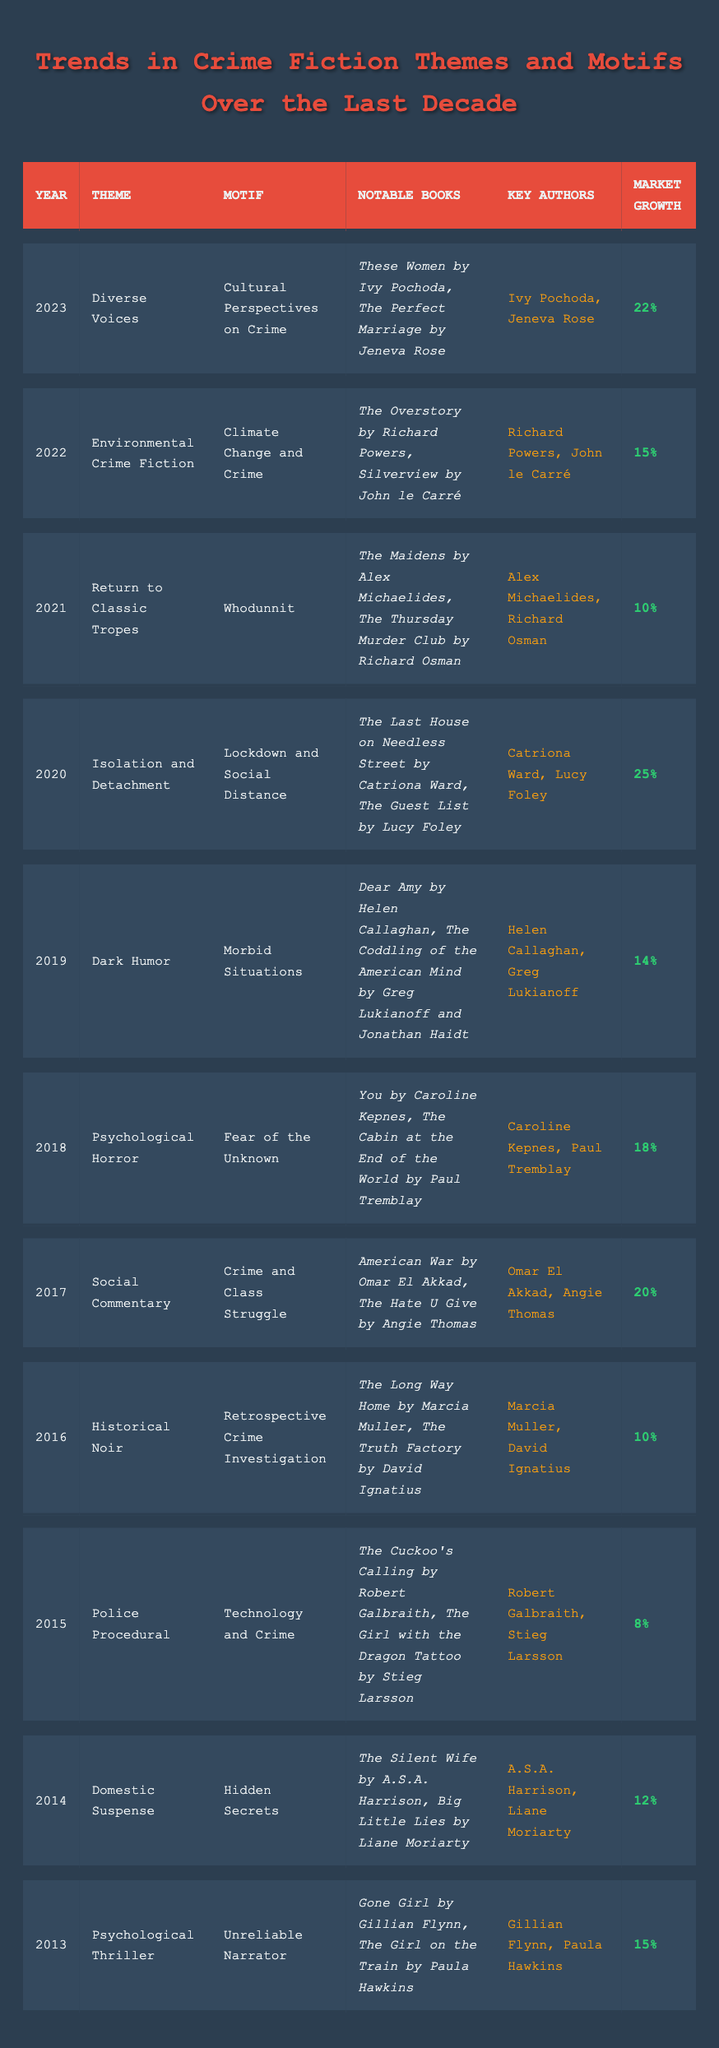What was the market growth percentage for the theme "Isolation and Detachment" in 2020? The table shows that the market growth for "Isolation and Detachment" in 2020 is listed as "25%."
Answer: 25% Which year had the highest market growth percentage? By reviewing the market growth values, "Isolation and Detachment" in 2020 has the highest market growth percentage at "25%."
Answer: 2020 What was the theme and motif associated with the year 2018? The table indicates that in 2018, the theme was "Psychological Horror" and the motif was "Fear of the Unknown."
Answer: Psychological Horror; Fear of the Unknown List the notable books associated with the "Diverse Voices" theme in 2023. The notable books listed for the theme "Diverse Voices" in 2023 are "These Women" by Ivy Pochoda and "The Perfect Marriage" by Jeneva Rose.
Answer: These Women, The Perfect Marriage How many themes had a market growth percentage greater than 15%? The themes with market growth percentages greater than 15% are "Social Commentary" (20%), "Psychological Horror" (18%), and "Isolation and Detachment" (25%). This gives a total of 3 themes.
Answer: 3 Is "Technology and Crime" the motif for the "Police Procedural" theme? According to the table, the motif for "Police Procedural" is listed as "Technology and Crime," so the statement is true.
Answer: Yes What is the average market growth percentage for the five years from 2015 to 2019? The market growth percentages for those years are: 8%, 10%, 20%, 18%, and 14%. Summing these results gives 70%, and dividing by 5 results in an average of 14%.
Answer: 14% Compare the market growth percentages for the themes between 2013 and 2014. The theme in 2013, "Psychological Thriller," had a market growth of "15%," while in 2014, "Domestic Suspense" had a market growth of "12%." The difference is 3%.
Answer: 3% What trend in crime fiction emerged in 2022, and who are the key authors associated with it? The trend in 2022 was "Environmental Crime Fiction," and the key authors listed are Richard Powers and John le Carré.
Answer: Environmental Crime Fiction; Richard Powers, John le Carré Was there a trend of increasing market growth percentages over the last decade? By analyzing the market growth percentages from each year, there are fluctuations, with some years showing an increase, but also some declines. Therefore, it is not a consistent trend of increase.
Answer: No 